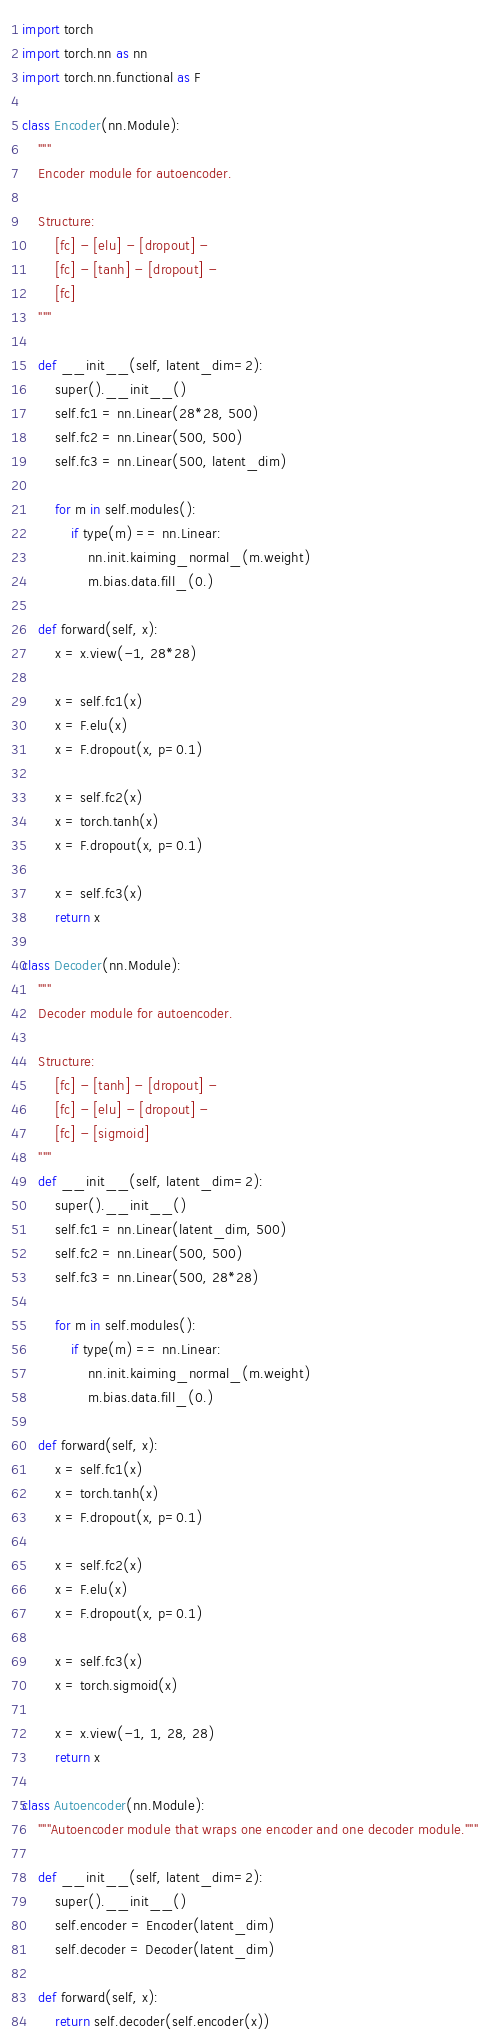Convert code to text. <code><loc_0><loc_0><loc_500><loc_500><_Python_>import torch
import torch.nn as nn
import torch.nn.functional as F

class Encoder(nn.Module):
	"""
	Encoder module for autoencoder.
	
	Structure:
		[fc] - [elu] - [dropout] - 
		[fc] - [tanh] - [dropout] -
		[fc]
	"""
	
	def __init__(self, latent_dim=2):
		super().__init__()
		self.fc1 = nn.Linear(28*28, 500)
		self.fc2 = nn.Linear(500, 500)
		self.fc3 = nn.Linear(500, latent_dim)
	
		for m in self.modules():
			if type(m) == nn.Linear:
				nn.init.kaiming_normal_(m.weight)
				m.bias.data.fill_(0.)
	
	def forward(self, x):
		x = x.view(-1, 28*28)
		
		x = self.fc1(x)
		x = F.elu(x)
		x = F.dropout(x, p=0.1)
		
		x = self.fc2(x)
		x = torch.tanh(x)
		x = F.dropout(x, p=0.1)
		
		x = self.fc3(x)
		return x

class Decoder(nn.Module):
	"""
	Decoder module for autoencoder.
	
	Structure:
		[fc] - [tanh] - [dropout] - 
		[fc] - [elu] - [dropout] -
		[fc] - [sigmoid]
	"""	
	def __init__(self, latent_dim=2):
		super().__init__()
		self.fc1 = nn.Linear(latent_dim, 500)
		self.fc2 = nn.Linear(500, 500)
		self.fc3 = nn.Linear(500, 28*28)
		
		for m in self.modules():
			if type(m) == nn.Linear:
				nn.init.kaiming_normal_(m.weight)
				m.bias.data.fill_(0.)
	
	def forward(self, x):
		x = self.fc1(x)
		x = torch.tanh(x)
		x = F.dropout(x, p=0.1)
		
		x = self.fc2(x)
		x = F.elu(x)
		x = F.dropout(x, p=0.1)
		
		x = self.fc3(x)
		x = torch.sigmoid(x)
		
		x = x.view(-1, 1, 28, 28)
		return x

class Autoencoder(nn.Module):
	"""Autoencoder module that wraps one encoder and one decoder module."""
	
	def __init__(self, latent_dim=2):
		super().__init__()
		self.encoder = Encoder(latent_dim)
		self.decoder = Decoder(latent_dim)
	
	def forward(self, x):
		return self.decoder(self.encoder(x))</code> 